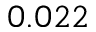Convert formula to latex. <formula><loc_0><loc_0><loc_500><loc_500>0 . 0 2 2</formula> 